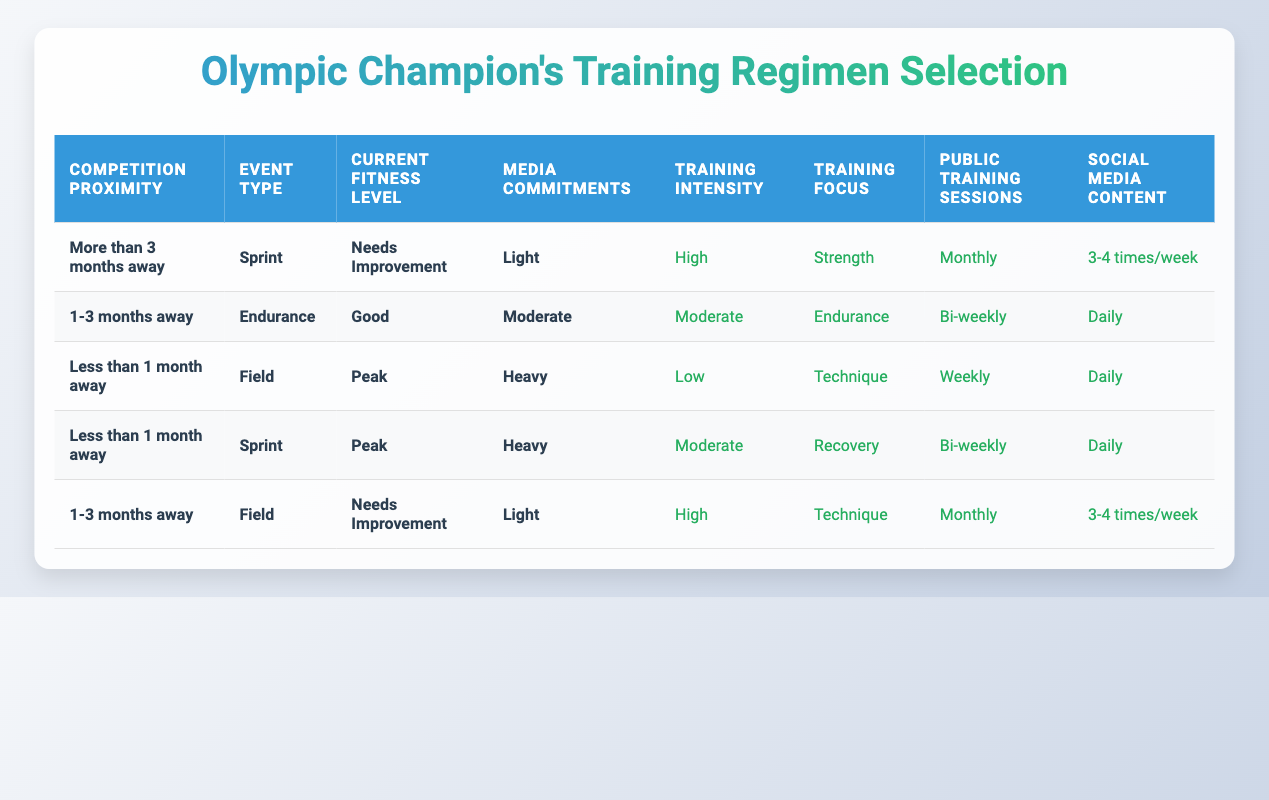What is the training intensity when a competition is less than 1 month away for a sprint event with a peak fitness level and heavy media commitments? According to the table, for the conditions of less than 1 month away, sprint event, peak fitness level, and heavy media commitments, the training intensity is listed as moderate.
Answer: Moderate How many times will public training sessions happen for an endurance event if the competition is 1-3 months away and the current fitness level is good with moderate media commitments? For an endurance event that is 1-3 months away with a good fitness level and moderate media commitments, the table shows that public training sessions will occur bi-weekly.
Answer: Bi-weekly Is the training focus for less than 1 month away in a field event with a peak fitness level and heavy media commitments set to recovery? The table indicates that for less than one month away in a field event with peak fitness level and heavy media commitments, the training focus is on technique, not recovery. Therefore, the statement is false.
Answer: No What is the consistent action related to social media content for all conditions listed in the table? Upon reviewing the table, social media content is generally set to daily for heavy media commitments and bi-weekly for other conditions, showing there is no consistent action across all conditions, as it varies based on media commitments.
Answer: None When there are heavy media commitments, what is the training intensity for events less than 1 month away? The table lists two scenarios for events less than 1 month away with heavy media commitments: for field events, the training intensity is low, while for sprint events, it is moderate. Thus, both intensities are applicable and vary based on the event type.
Answer: Varies (Low for Field, Moderate for Sprint) What is the average number of public training sessions held for all conditions involving needs improvement current fitness level? The applicable scenarios for needs improvement fitness are: 1 monthly session for sprint (more than 3 months away) and 1 monthly session for field (1-3 months away). Since both result in monthly sessions, the average is (1+1)/2 = 1.
Answer: 1 If the event type is a sprint and the fitness level needs improvement, how often are training sessions publicly held? Referring to the table, when the event type is a sprint with needs improvement fitness level and light media commitments, public training sessions are set to occur monthly.
Answer: Monthly How does the training focus for endurance events change based on current fitness levels? The table shows that for endurance events, the training focus is on endurance when current fitness is good, while no scenario for needs improvement is provided. Thus, the only focus indicated is endurance for good fitness level.
Answer: Endurance (only for good fitness) 